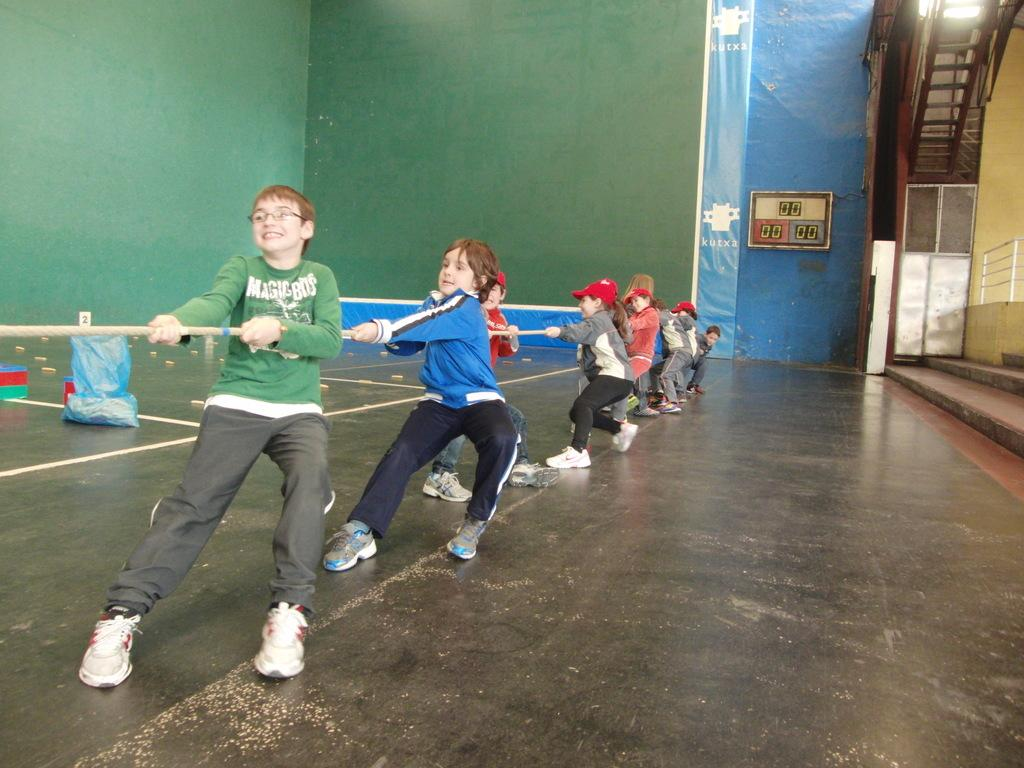Who are the subjects in the image? There are kids in the image. What are the kids doing in the image? The kids are pulling a rope. What can be seen in the background of the image? There is a wall visible in the background of the image. What type of rail is being used by the porter in the image? There is no porter or rail present in the image; it features kids pulling a rope with a wall in the background. 